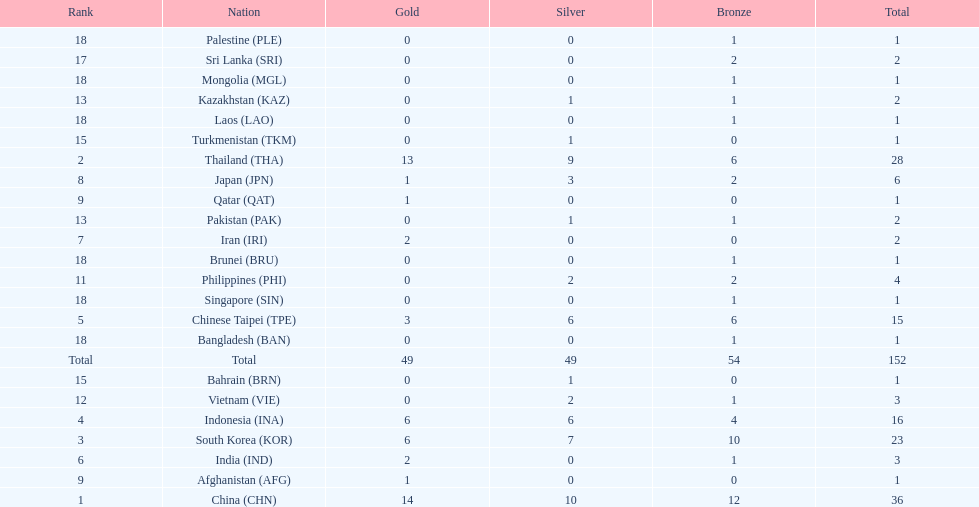What was the number of medals earned by indonesia (ina) ? 16. 